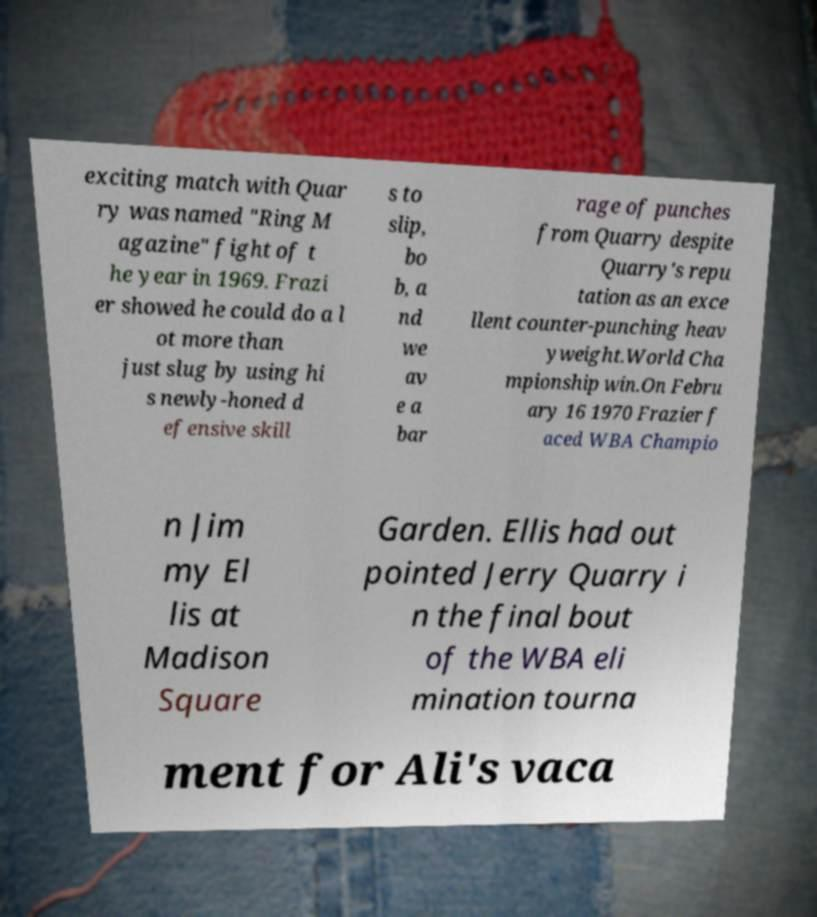Can you accurately transcribe the text from the provided image for me? exciting match with Quar ry was named "Ring M agazine" fight of t he year in 1969. Frazi er showed he could do a l ot more than just slug by using hi s newly-honed d efensive skill s to slip, bo b, a nd we av e a bar rage of punches from Quarry despite Quarry's repu tation as an exce llent counter-punching heav yweight.World Cha mpionship win.On Febru ary 16 1970 Frazier f aced WBA Champio n Jim my El lis at Madison Square Garden. Ellis had out pointed Jerry Quarry i n the final bout of the WBA eli mination tourna ment for Ali's vaca 